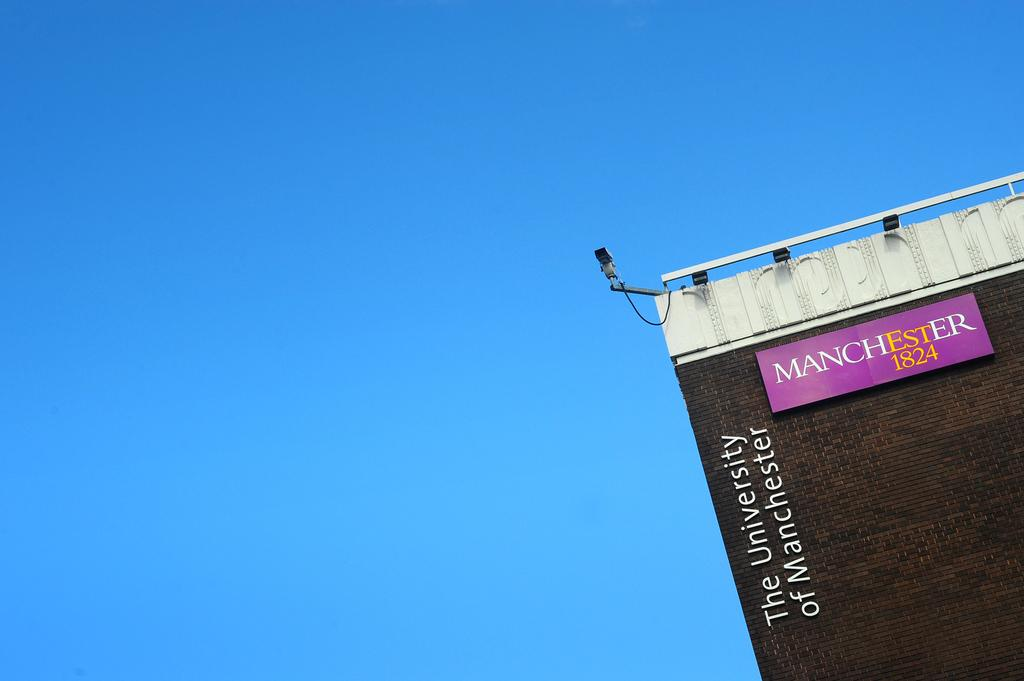<image>
Create a compact narrative representing the image presented. The corner of a building that says The University of Manchester 